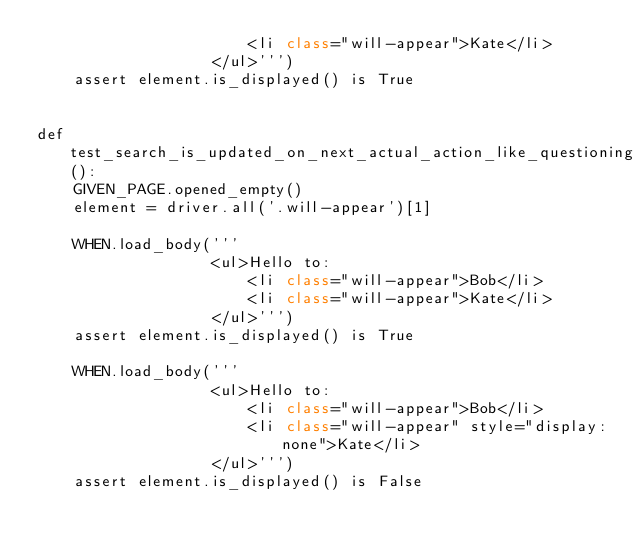<code> <loc_0><loc_0><loc_500><loc_500><_Python_>                       <li class="will-appear">Kate</li>
                   </ul>''')
    assert element.is_displayed() is True


def test_search_is_updated_on_next_actual_action_like_questioning_displayed():
    GIVEN_PAGE.opened_empty()
    element = driver.all('.will-appear')[1]

    WHEN.load_body('''
                   <ul>Hello to:
                       <li class="will-appear">Bob</li>
                       <li class="will-appear">Kate</li>
                   </ul>''')
    assert element.is_displayed() is True

    WHEN.load_body('''
                   <ul>Hello to:
                       <li class="will-appear">Bob</li>
                       <li class="will-appear" style="display:none">Kate</li>
                   </ul>''')
    assert element.is_displayed() is False
</code> 